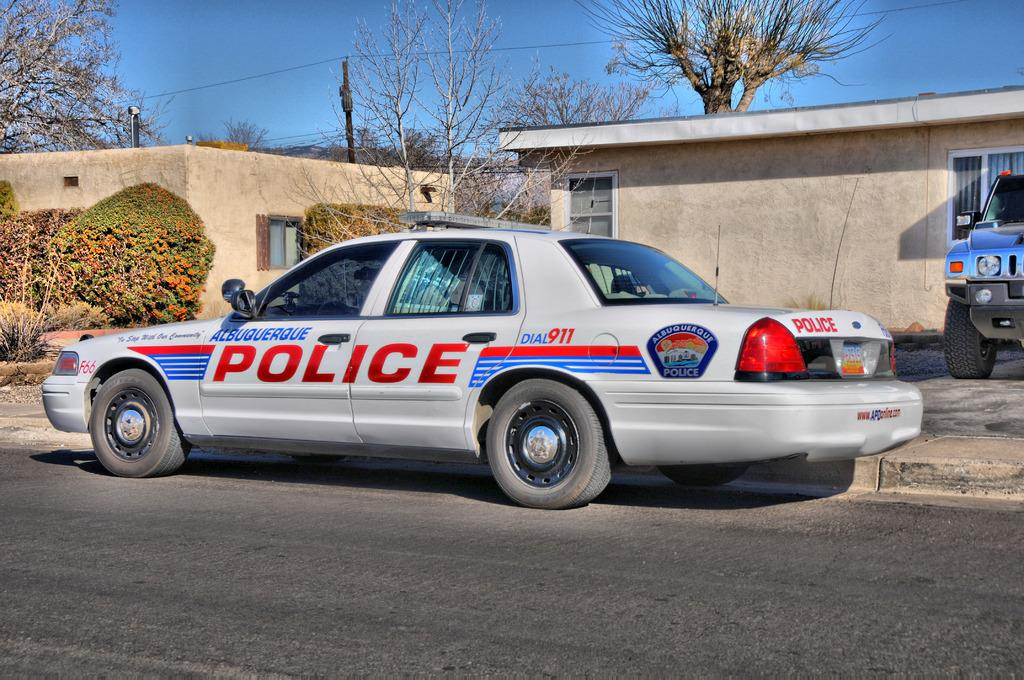<image>
Give a short and clear explanation of the subsequent image. A white car says Albuquerque Police and is parked outside a tan building. 